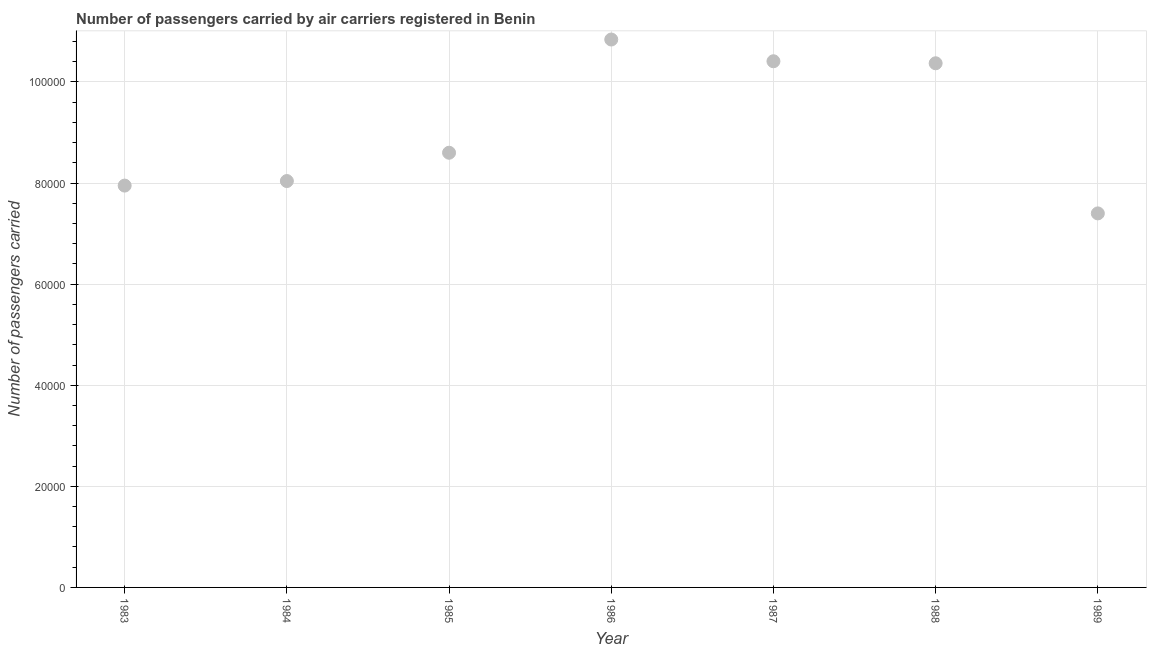What is the number of passengers carried in 1983?
Give a very brief answer. 7.95e+04. Across all years, what is the maximum number of passengers carried?
Make the answer very short. 1.08e+05. Across all years, what is the minimum number of passengers carried?
Give a very brief answer. 7.40e+04. In which year was the number of passengers carried maximum?
Keep it short and to the point. 1986. In which year was the number of passengers carried minimum?
Your answer should be compact. 1989. What is the sum of the number of passengers carried?
Offer a terse response. 6.36e+05. What is the difference between the number of passengers carried in 1987 and 1989?
Your answer should be very brief. 3.01e+04. What is the average number of passengers carried per year?
Your answer should be very brief. 9.09e+04. What is the median number of passengers carried?
Your answer should be very brief. 8.60e+04. Do a majority of the years between 1985 and 1988 (inclusive) have number of passengers carried greater than 92000 ?
Offer a terse response. Yes. What is the ratio of the number of passengers carried in 1983 to that in 1989?
Offer a terse response. 1.07. Is the difference between the number of passengers carried in 1985 and 1987 greater than the difference between any two years?
Make the answer very short. No. What is the difference between the highest and the second highest number of passengers carried?
Your answer should be compact. 4300. What is the difference between the highest and the lowest number of passengers carried?
Your answer should be very brief. 3.44e+04. In how many years, is the number of passengers carried greater than the average number of passengers carried taken over all years?
Offer a terse response. 3. Does the number of passengers carried monotonically increase over the years?
Provide a short and direct response. No. Are the values on the major ticks of Y-axis written in scientific E-notation?
Make the answer very short. No. What is the title of the graph?
Offer a terse response. Number of passengers carried by air carriers registered in Benin. What is the label or title of the X-axis?
Your answer should be compact. Year. What is the label or title of the Y-axis?
Give a very brief answer. Number of passengers carried. What is the Number of passengers carried in 1983?
Your answer should be compact. 7.95e+04. What is the Number of passengers carried in 1984?
Give a very brief answer. 8.04e+04. What is the Number of passengers carried in 1985?
Your answer should be compact. 8.60e+04. What is the Number of passengers carried in 1986?
Make the answer very short. 1.08e+05. What is the Number of passengers carried in 1987?
Ensure brevity in your answer.  1.04e+05. What is the Number of passengers carried in 1988?
Your answer should be very brief. 1.04e+05. What is the Number of passengers carried in 1989?
Offer a very short reply. 7.40e+04. What is the difference between the Number of passengers carried in 1983 and 1984?
Your response must be concise. -900. What is the difference between the Number of passengers carried in 1983 and 1985?
Give a very brief answer. -6500. What is the difference between the Number of passengers carried in 1983 and 1986?
Offer a terse response. -2.89e+04. What is the difference between the Number of passengers carried in 1983 and 1987?
Give a very brief answer. -2.46e+04. What is the difference between the Number of passengers carried in 1983 and 1988?
Your answer should be compact. -2.42e+04. What is the difference between the Number of passengers carried in 1983 and 1989?
Your response must be concise. 5500. What is the difference between the Number of passengers carried in 1984 and 1985?
Keep it short and to the point. -5600. What is the difference between the Number of passengers carried in 1984 and 1986?
Your response must be concise. -2.80e+04. What is the difference between the Number of passengers carried in 1984 and 1987?
Your answer should be very brief. -2.37e+04. What is the difference between the Number of passengers carried in 1984 and 1988?
Your answer should be very brief. -2.33e+04. What is the difference between the Number of passengers carried in 1984 and 1989?
Make the answer very short. 6400. What is the difference between the Number of passengers carried in 1985 and 1986?
Make the answer very short. -2.24e+04. What is the difference between the Number of passengers carried in 1985 and 1987?
Give a very brief answer. -1.81e+04. What is the difference between the Number of passengers carried in 1985 and 1988?
Offer a terse response. -1.77e+04. What is the difference between the Number of passengers carried in 1985 and 1989?
Your answer should be very brief. 1.20e+04. What is the difference between the Number of passengers carried in 1986 and 1987?
Your answer should be compact. 4300. What is the difference between the Number of passengers carried in 1986 and 1988?
Offer a terse response. 4700. What is the difference between the Number of passengers carried in 1986 and 1989?
Your answer should be very brief. 3.44e+04. What is the difference between the Number of passengers carried in 1987 and 1988?
Your response must be concise. 400. What is the difference between the Number of passengers carried in 1987 and 1989?
Your response must be concise. 3.01e+04. What is the difference between the Number of passengers carried in 1988 and 1989?
Keep it short and to the point. 2.97e+04. What is the ratio of the Number of passengers carried in 1983 to that in 1985?
Give a very brief answer. 0.92. What is the ratio of the Number of passengers carried in 1983 to that in 1986?
Provide a short and direct response. 0.73. What is the ratio of the Number of passengers carried in 1983 to that in 1987?
Keep it short and to the point. 0.76. What is the ratio of the Number of passengers carried in 1983 to that in 1988?
Provide a short and direct response. 0.77. What is the ratio of the Number of passengers carried in 1983 to that in 1989?
Provide a succinct answer. 1.07. What is the ratio of the Number of passengers carried in 1984 to that in 1985?
Make the answer very short. 0.94. What is the ratio of the Number of passengers carried in 1984 to that in 1986?
Make the answer very short. 0.74. What is the ratio of the Number of passengers carried in 1984 to that in 1987?
Ensure brevity in your answer.  0.77. What is the ratio of the Number of passengers carried in 1984 to that in 1988?
Your answer should be very brief. 0.78. What is the ratio of the Number of passengers carried in 1984 to that in 1989?
Your answer should be very brief. 1.09. What is the ratio of the Number of passengers carried in 1985 to that in 1986?
Your response must be concise. 0.79. What is the ratio of the Number of passengers carried in 1985 to that in 1987?
Your response must be concise. 0.83. What is the ratio of the Number of passengers carried in 1985 to that in 1988?
Keep it short and to the point. 0.83. What is the ratio of the Number of passengers carried in 1985 to that in 1989?
Provide a succinct answer. 1.16. What is the ratio of the Number of passengers carried in 1986 to that in 1987?
Give a very brief answer. 1.04. What is the ratio of the Number of passengers carried in 1986 to that in 1988?
Offer a terse response. 1.04. What is the ratio of the Number of passengers carried in 1986 to that in 1989?
Keep it short and to the point. 1.47. What is the ratio of the Number of passengers carried in 1987 to that in 1989?
Your answer should be very brief. 1.41. What is the ratio of the Number of passengers carried in 1988 to that in 1989?
Your response must be concise. 1.4. 